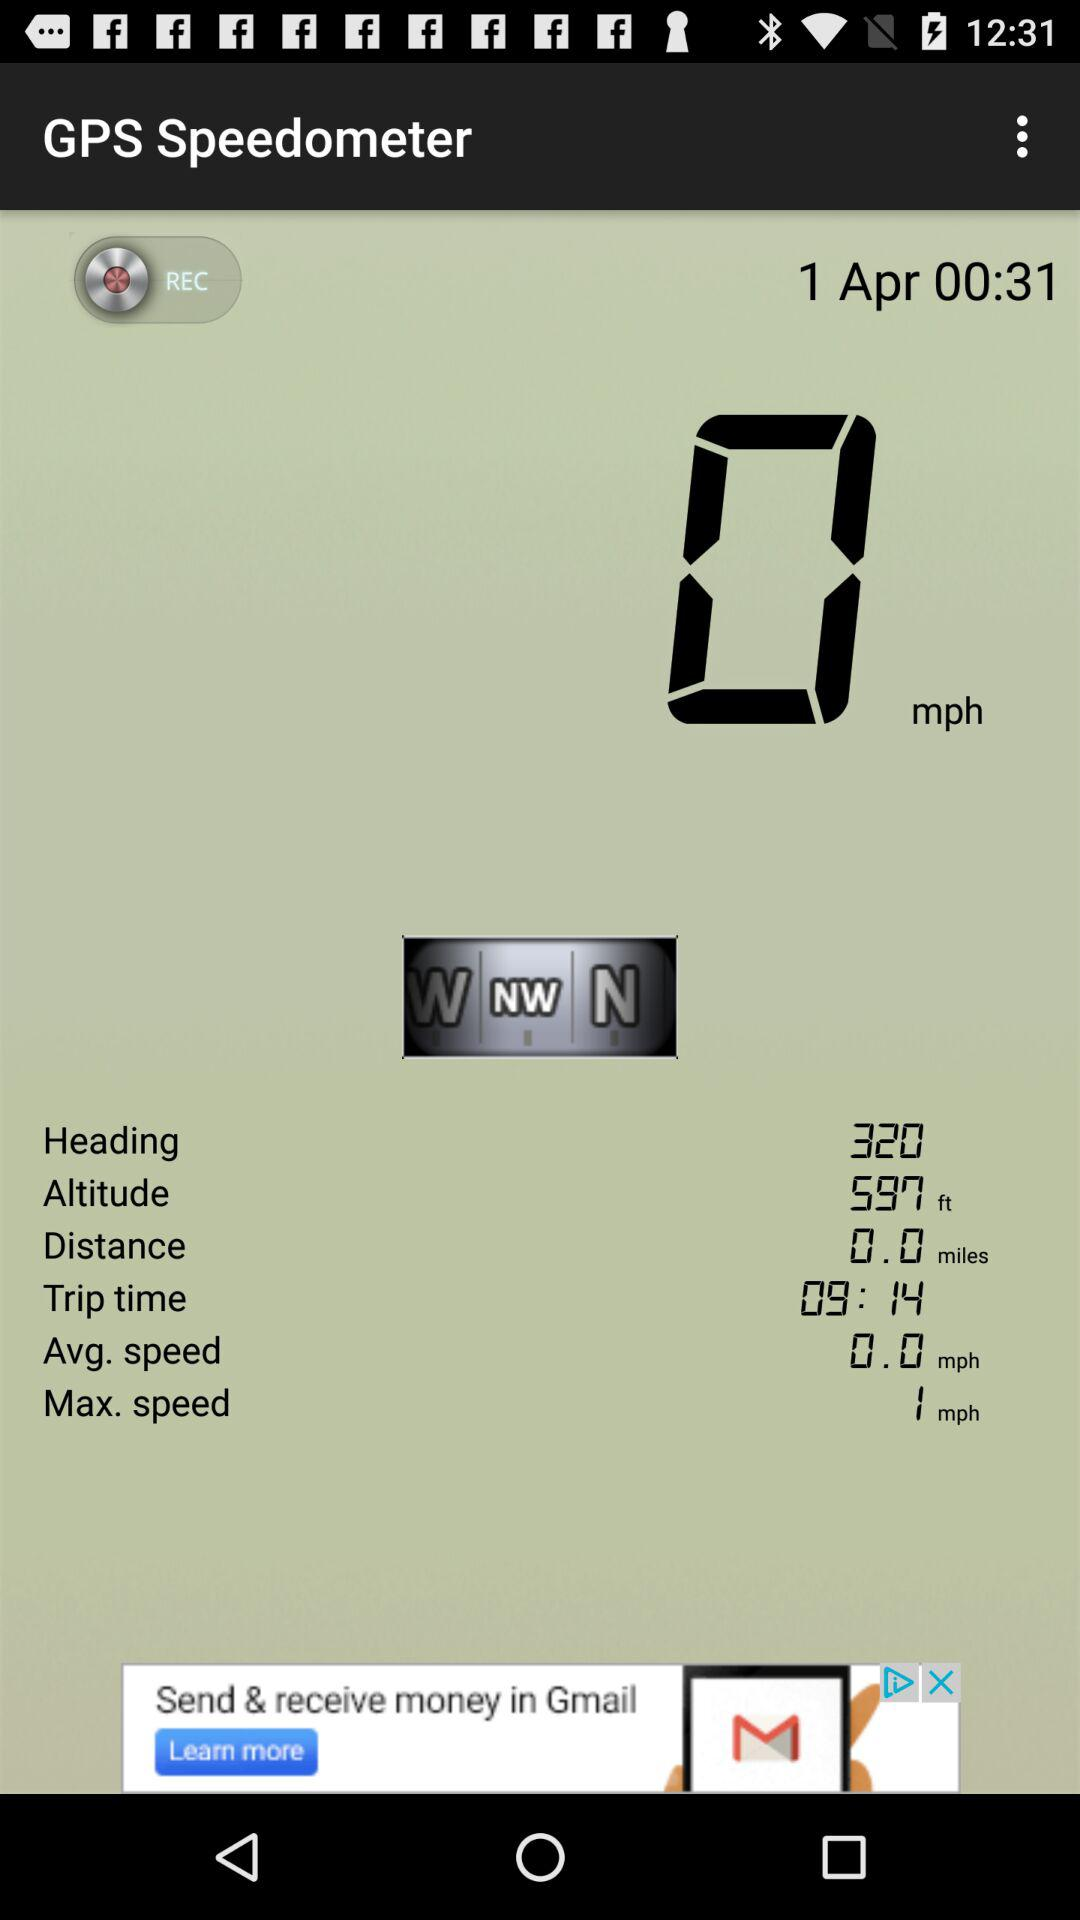How much is the distance? The distance is 0.0 miles. 